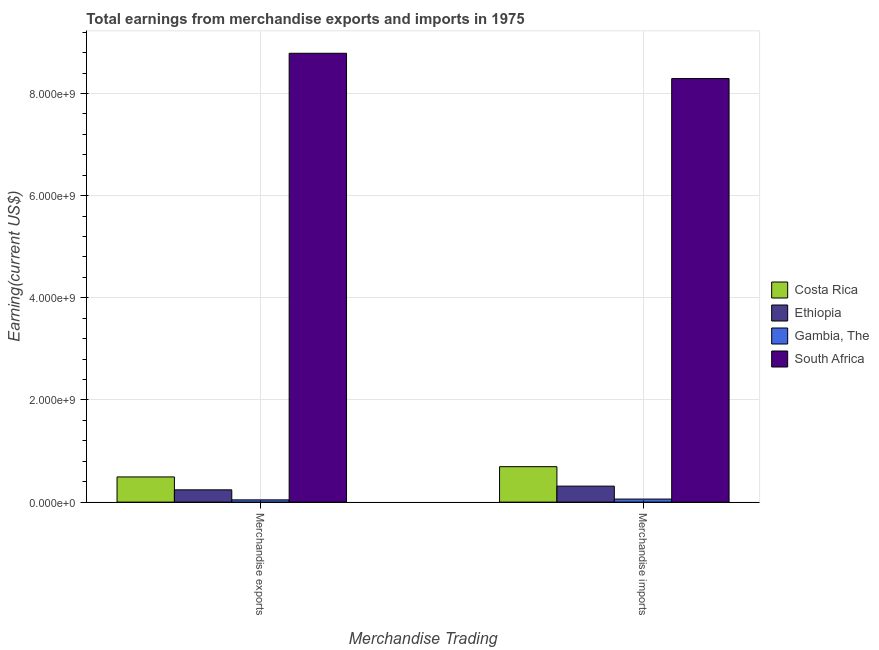How many different coloured bars are there?
Offer a terse response. 4. How many groups of bars are there?
Provide a short and direct response. 2. Are the number of bars per tick equal to the number of legend labels?
Offer a terse response. Yes. How many bars are there on the 2nd tick from the right?
Give a very brief answer. 4. What is the label of the 2nd group of bars from the left?
Ensure brevity in your answer.  Merchandise imports. What is the earnings from merchandise imports in Gambia, The?
Your response must be concise. 5.97e+07. Across all countries, what is the maximum earnings from merchandise exports?
Keep it short and to the point. 8.79e+09. Across all countries, what is the minimum earnings from merchandise exports?
Provide a short and direct response. 4.42e+07. In which country was the earnings from merchandise exports maximum?
Offer a very short reply. South Africa. In which country was the earnings from merchandise exports minimum?
Make the answer very short. Gambia, The. What is the total earnings from merchandise imports in the graph?
Your answer should be compact. 9.36e+09. What is the difference between the earnings from merchandise exports in Gambia, The and that in Costa Rica?
Offer a very short reply. -4.49e+08. What is the difference between the earnings from merchandise imports in Ethiopia and the earnings from merchandise exports in South Africa?
Keep it short and to the point. -8.48e+09. What is the average earnings from merchandise imports per country?
Your response must be concise. 2.34e+09. What is the difference between the earnings from merchandise imports and earnings from merchandise exports in Gambia, The?
Your answer should be compact. 1.54e+07. In how many countries, is the earnings from merchandise exports greater than 4800000000 US$?
Offer a very short reply. 1. What is the ratio of the earnings from merchandise exports in Gambia, The to that in South Africa?
Offer a very short reply. 0.01. Is the earnings from merchandise exports in Costa Rica less than that in Ethiopia?
Give a very brief answer. No. What does the 4th bar from the left in Merchandise imports represents?
Ensure brevity in your answer.  South Africa. What does the 4th bar from the right in Merchandise exports represents?
Give a very brief answer. Costa Rica. Are all the bars in the graph horizontal?
Make the answer very short. No. How many countries are there in the graph?
Provide a short and direct response. 4. Are the values on the major ticks of Y-axis written in scientific E-notation?
Give a very brief answer. Yes. Does the graph contain any zero values?
Your answer should be compact. No. What is the title of the graph?
Your answer should be compact. Total earnings from merchandise exports and imports in 1975. Does "St. Kitts and Nevis" appear as one of the legend labels in the graph?
Provide a succinct answer. No. What is the label or title of the X-axis?
Provide a succinct answer. Merchandise Trading. What is the label or title of the Y-axis?
Keep it short and to the point. Earning(current US$). What is the Earning(current US$) in Costa Rica in Merchandise exports?
Your response must be concise. 4.93e+08. What is the Earning(current US$) of Ethiopia in Merchandise exports?
Ensure brevity in your answer.  2.40e+08. What is the Earning(current US$) in Gambia, The in Merchandise exports?
Give a very brief answer. 4.42e+07. What is the Earning(current US$) in South Africa in Merchandise exports?
Your answer should be compact. 8.79e+09. What is the Earning(current US$) of Costa Rica in Merchandise imports?
Ensure brevity in your answer.  6.94e+08. What is the Earning(current US$) in Ethiopia in Merchandise imports?
Give a very brief answer. 3.13e+08. What is the Earning(current US$) of Gambia, The in Merchandise imports?
Make the answer very short. 5.97e+07. What is the Earning(current US$) of South Africa in Merchandise imports?
Keep it short and to the point. 8.29e+09. Across all Merchandise Trading, what is the maximum Earning(current US$) in Costa Rica?
Provide a short and direct response. 6.94e+08. Across all Merchandise Trading, what is the maximum Earning(current US$) in Ethiopia?
Your response must be concise. 3.13e+08. Across all Merchandise Trading, what is the maximum Earning(current US$) of Gambia, The?
Your response must be concise. 5.97e+07. Across all Merchandise Trading, what is the maximum Earning(current US$) in South Africa?
Offer a very short reply. 8.79e+09. Across all Merchandise Trading, what is the minimum Earning(current US$) of Costa Rica?
Your answer should be very brief. 4.93e+08. Across all Merchandise Trading, what is the minimum Earning(current US$) in Ethiopia?
Ensure brevity in your answer.  2.40e+08. Across all Merchandise Trading, what is the minimum Earning(current US$) in Gambia, The?
Provide a succinct answer. 4.42e+07. Across all Merchandise Trading, what is the minimum Earning(current US$) in South Africa?
Provide a short and direct response. 8.29e+09. What is the total Earning(current US$) of Costa Rica in the graph?
Your response must be concise. 1.19e+09. What is the total Earning(current US$) in Ethiopia in the graph?
Provide a succinct answer. 5.53e+08. What is the total Earning(current US$) in Gambia, The in the graph?
Offer a very short reply. 1.04e+08. What is the total Earning(current US$) of South Africa in the graph?
Your answer should be compact. 1.71e+1. What is the difference between the Earning(current US$) in Costa Rica in Merchandise exports and that in Merchandise imports?
Your answer should be compact. -2.01e+08. What is the difference between the Earning(current US$) in Ethiopia in Merchandise exports and that in Merchandise imports?
Keep it short and to the point. -7.25e+07. What is the difference between the Earning(current US$) in Gambia, The in Merchandise exports and that in Merchandise imports?
Ensure brevity in your answer.  -1.54e+07. What is the difference between the Earning(current US$) of South Africa in Merchandise exports and that in Merchandise imports?
Your answer should be very brief. 4.95e+08. What is the difference between the Earning(current US$) of Costa Rica in Merchandise exports and the Earning(current US$) of Ethiopia in Merchandise imports?
Offer a terse response. 1.80e+08. What is the difference between the Earning(current US$) in Costa Rica in Merchandise exports and the Earning(current US$) in Gambia, The in Merchandise imports?
Provide a short and direct response. 4.34e+08. What is the difference between the Earning(current US$) of Costa Rica in Merchandise exports and the Earning(current US$) of South Africa in Merchandise imports?
Provide a succinct answer. -7.80e+09. What is the difference between the Earning(current US$) of Ethiopia in Merchandise exports and the Earning(current US$) of Gambia, The in Merchandise imports?
Your answer should be compact. 1.81e+08. What is the difference between the Earning(current US$) in Ethiopia in Merchandise exports and the Earning(current US$) in South Africa in Merchandise imports?
Your answer should be compact. -8.05e+09. What is the difference between the Earning(current US$) in Gambia, The in Merchandise exports and the Earning(current US$) in South Africa in Merchandise imports?
Make the answer very short. -8.25e+09. What is the average Earning(current US$) in Costa Rica per Merchandise Trading?
Provide a succinct answer. 5.94e+08. What is the average Earning(current US$) of Ethiopia per Merchandise Trading?
Your answer should be compact. 2.77e+08. What is the average Earning(current US$) of Gambia, The per Merchandise Trading?
Ensure brevity in your answer.  5.20e+07. What is the average Earning(current US$) of South Africa per Merchandise Trading?
Give a very brief answer. 8.54e+09. What is the difference between the Earning(current US$) in Costa Rica and Earning(current US$) in Ethiopia in Merchandise exports?
Your answer should be compact. 2.53e+08. What is the difference between the Earning(current US$) of Costa Rica and Earning(current US$) of Gambia, The in Merchandise exports?
Your response must be concise. 4.49e+08. What is the difference between the Earning(current US$) of Costa Rica and Earning(current US$) of South Africa in Merchandise exports?
Keep it short and to the point. -8.30e+09. What is the difference between the Earning(current US$) in Ethiopia and Earning(current US$) in Gambia, The in Merchandise exports?
Ensure brevity in your answer.  1.96e+08. What is the difference between the Earning(current US$) in Ethiopia and Earning(current US$) in South Africa in Merchandise exports?
Your answer should be very brief. -8.55e+09. What is the difference between the Earning(current US$) in Gambia, The and Earning(current US$) in South Africa in Merchandise exports?
Your answer should be compact. -8.74e+09. What is the difference between the Earning(current US$) in Costa Rica and Earning(current US$) in Ethiopia in Merchandise imports?
Offer a terse response. 3.81e+08. What is the difference between the Earning(current US$) of Costa Rica and Earning(current US$) of Gambia, The in Merchandise imports?
Keep it short and to the point. 6.34e+08. What is the difference between the Earning(current US$) in Costa Rica and Earning(current US$) in South Africa in Merchandise imports?
Ensure brevity in your answer.  -7.60e+09. What is the difference between the Earning(current US$) of Ethiopia and Earning(current US$) of Gambia, The in Merchandise imports?
Offer a very short reply. 2.53e+08. What is the difference between the Earning(current US$) in Ethiopia and Earning(current US$) in South Africa in Merchandise imports?
Keep it short and to the point. -7.98e+09. What is the difference between the Earning(current US$) in Gambia, The and Earning(current US$) in South Africa in Merchandise imports?
Offer a very short reply. -8.23e+09. What is the ratio of the Earning(current US$) of Costa Rica in Merchandise exports to that in Merchandise imports?
Your answer should be compact. 0.71. What is the ratio of the Earning(current US$) of Ethiopia in Merchandise exports to that in Merchandise imports?
Ensure brevity in your answer.  0.77. What is the ratio of the Earning(current US$) in Gambia, The in Merchandise exports to that in Merchandise imports?
Keep it short and to the point. 0.74. What is the ratio of the Earning(current US$) in South Africa in Merchandise exports to that in Merchandise imports?
Ensure brevity in your answer.  1.06. What is the difference between the highest and the second highest Earning(current US$) of Costa Rica?
Your response must be concise. 2.01e+08. What is the difference between the highest and the second highest Earning(current US$) of Ethiopia?
Provide a short and direct response. 7.25e+07. What is the difference between the highest and the second highest Earning(current US$) in Gambia, The?
Provide a short and direct response. 1.54e+07. What is the difference between the highest and the second highest Earning(current US$) in South Africa?
Provide a short and direct response. 4.95e+08. What is the difference between the highest and the lowest Earning(current US$) of Costa Rica?
Offer a very short reply. 2.01e+08. What is the difference between the highest and the lowest Earning(current US$) in Ethiopia?
Give a very brief answer. 7.25e+07. What is the difference between the highest and the lowest Earning(current US$) of Gambia, The?
Keep it short and to the point. 1.54e+07. What is the difference between the highest and the lowest Earning(current US$) in South Africa?
Your answer should be compact. 4.95e+08. 